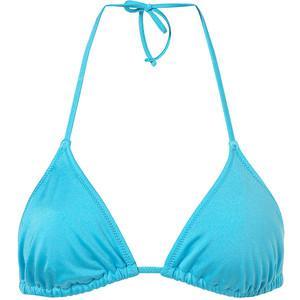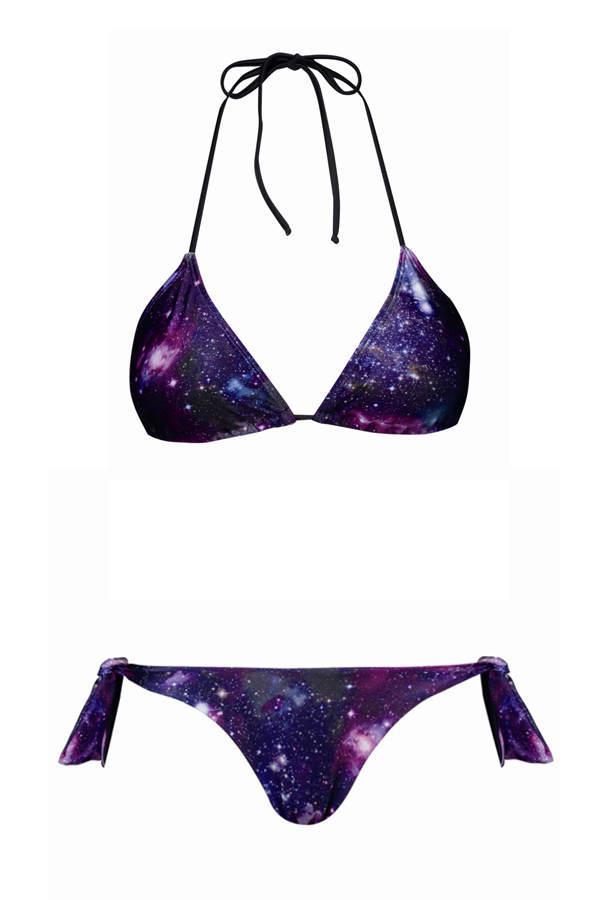The first image is the image on the left, the second image is the image on the right. Given the left and right images, does the statement "At lease one of the swimsuits is pink." hold true? Answer yes or no. No. 